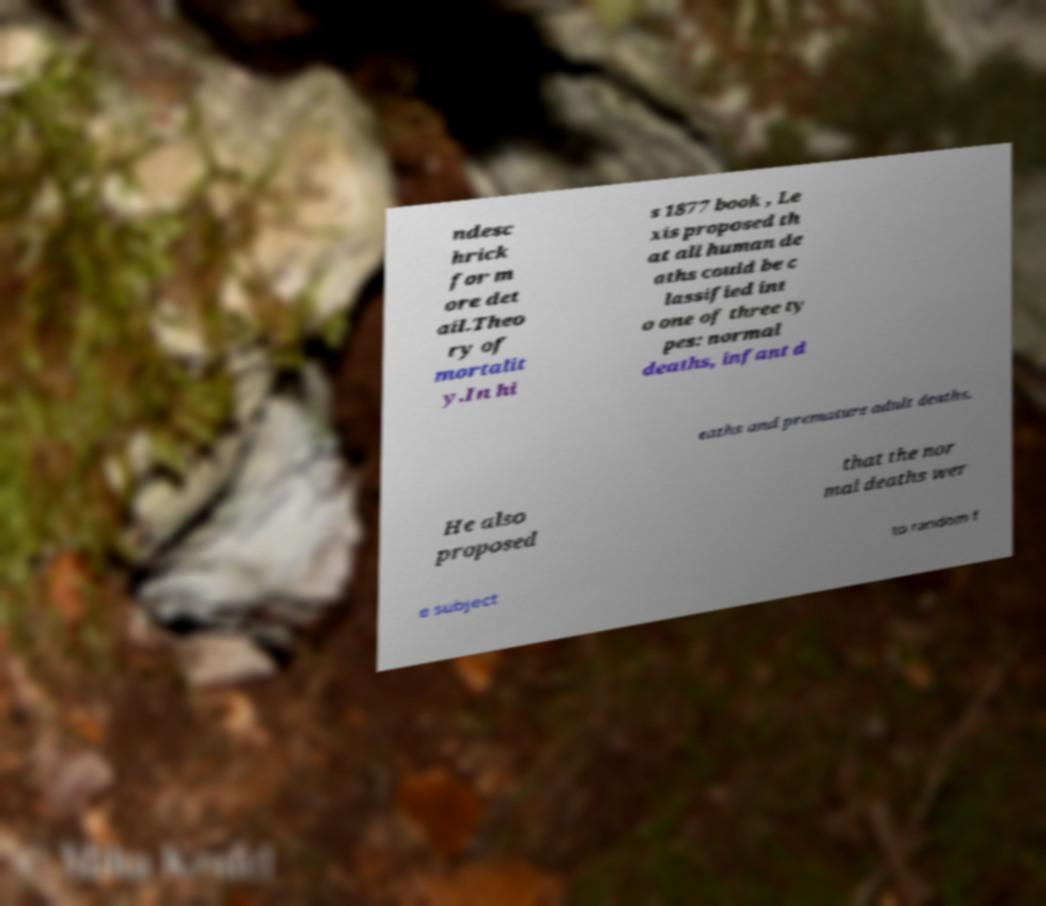Please identify and transcribe the text found in this image. ndesc hrick for m ore det ail.Theo ry of mortalit y.In hi s 1877 book , Le xis proposed th at all human de aths could be c lassified int o one of three ty pes: normal deaths, infant d eaths and premature adult deaths. He also proposed that the nor mal deaths wer e subject to random f 